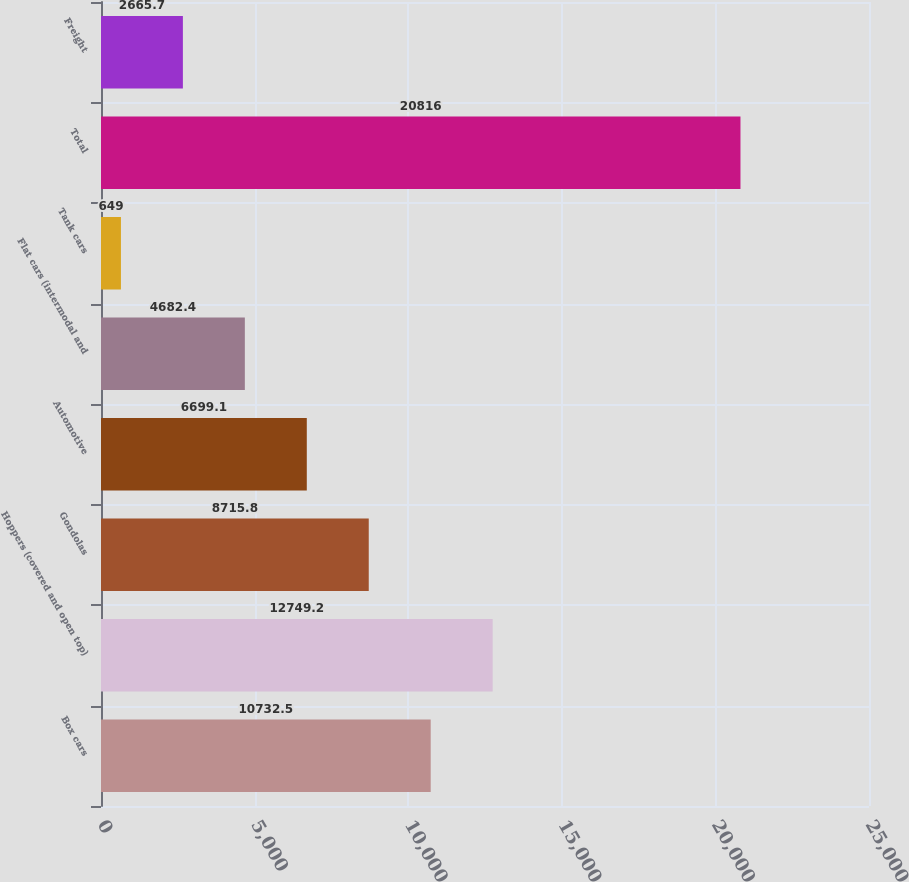Convert chart to OTSL. <chart><loc_0><loc_0><loc_500><loc_500><bar_chart><fcel>Box cars<fcel>Hoppers (covered and open top)<fcel>Gondolas<fcel>Automotive<fcel>Flat cars (intermodal and<fcel>Tank cars<fcel>Total<fcel>Freight<nl><fcel>10732.5<fcel>12749.2<fcel>8715.8<fcel>6699.1<fcel>4682.4<fcel>649<fcel>20816<fcel>2665.7<nl></chart> 